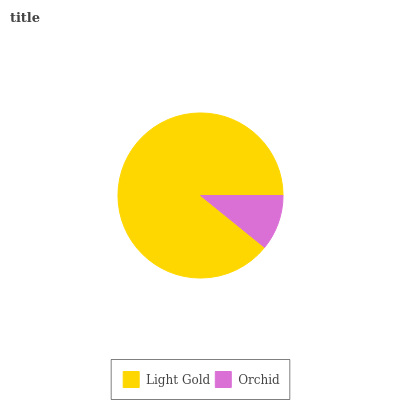Is Orchid the minimum?
Answer yes or no. Yes. Is Light Gold the maximum?
Answer yes or no. Yes. Is Orchid the maximum?
Answer yes or no. No. Is Light Gold greater than Orchid?
Answer yes or no. Yes. Is Orchid less than Light Gold?
Answer yes or no. Yes. Is Orchid greater than Light Gold?
Answer yes or no. No. Is Light Gold less than Orchid?
Answer yes or no. No. Is Light Gold the high median?
Answer yes or no. Yes. Is Orchid the low median?
Answer yes or no. Yes. Is Orchid the high median?
Answer yes or no. No. Is Light Gold the low median?
Answer yes or no. No. 